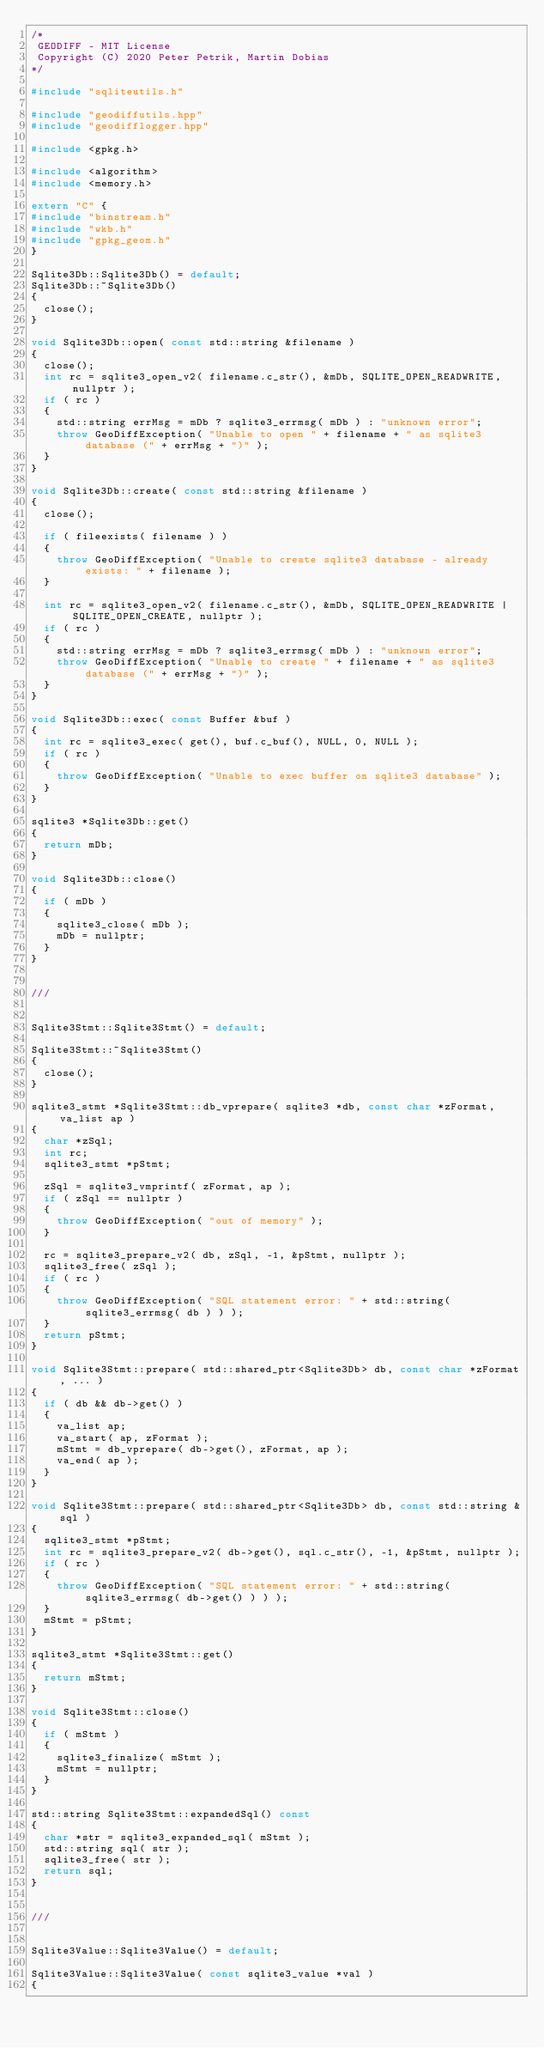Convert code to text. <code><loc_0><loc_0><loc_500><loc_500><_C++_>/*
 GEODIFF - MIT License
 Copyright (C) 2020 Peter Petrik, Martin Dobias
*/

#include "sqliteutils.h"

#include "geodiffutils.hpp"
#include "geodifflogger.hpp"

#include <gpkg.h>

#include <algorithm>
#include <memory.h>

extern "C" {
#include "binstream.h"
#include "wkb.h"
#include "gpkg_geom.h"
}

Sqlite3Db::Sqlite3Db() = default;
Sqlite3Db::~Sqlite3Db()
{
  close();
}

void Sqlite3Db::open( const std::string &filename )
{
  close();
  int rc = sqlite3_open_v2( filename.c_str(), &mDb, SQLITE_OPEN_READWRITE, nullptr );
  if ( rc )
  {
    std::string errMsg = mDb ? sqlite3_errmsg( mDb ) : "unknown error";
    throw GeoDiffException( "Unable to open " + filename + " as sqlite3 database (" + errMsg + ")" );
  }
}

void Sqlite3Db::create( const std::string &filename )
{
  close();

  if ( fileexists( filename ) )
  {
    throw GeoDiffException( "Unable to create sqlite3 database - already exists: " + filename );
  }

  int rc = sqlite3_open_v2( filename.c_str(), &mDb, SQLITE_OPEN_READWRITE | SQLITE_OPEN_CREATE, nullptr );
  if ( rc )
  {
    std::string errMsg = mDb ? sqlite3_errmsg( mDb ) : "unknown error";
    throw GeoDiffException( "Unable to create " + filename + " as sqlite3 database (" + errMsg + ")" );
  }
}

void Sqlite3Db::exec( const Buffer &buf )
{
  int rc = sqlite3_exec( get(), buf.c_buf(), NULL, 0, NULL );
  if ( rc )
  {
    throw GeoDiffException( "Unable to exec buffer on sqlite3 database" );
  }
}

sqlite3 *Sqlite3Db::get()
{
  return mDb;
}

void Sqlite3Db::close()
{
  if ( mDb )
  {
    sqlite3_close( mDb );
    mDb = nullptr;
  }
}


///


Sqlite3Stmt::Sqlite3Stmt() = default;

Sqlite3Stmt::~Sqlite3Stmt()
{
  close();
}

sqlite3_stmt *Sqlite3Stmt::db_vprepare( sqlite3 *db, const char *zFormat, va_list ap )
{
  char *zSql;
  int rc;
  sqlite3_stmt *pStmt;

  zSql = sqlite3_vmprintf( zFormat, ap );
  if ( zSql == nullptr )
  {
    throw GeoDiffException( "out of memory" );
  }

  rc = sqlite3_prepare_v2( db, zSql, -1, &pStmt, nullptr );
  sqlite3_free( zSql );
  if ( rc )
  {
    throw GeoDiffException( "SQL statement error: " + std::string( sqlite3_errmsg( db ) ) );
  }
  return pStmt;
}

void Sqlite3Stmt::prepare( std::shared_ptr<Sqlite3Db> db, const char *zFormat, ... )
{
  if ( db && db->get() )
  {
    va_list ap;
    va_start( ap, zFormat );
    mStmt = db_vprepare( db->get(), zFormat, ap );
    va_end( ap );
  }
}

void Sqlite3Stmt::prepare( std::shared_ptr<Sqlite3Db> db, const std::string &sql )
{
  sqlite3_stmt *pStmt;
  int rc = sqlite3_prepare_v2( db->get(), sql.c_str(), -1, &pStmt, nullptr );
  if ( rc )
  {
    throw GeoDiffException( "SQL statement error: " + std::string( sqlite3_errmsg( db->get() ) ) );
  }
  mStmt = pStmt;
}

sqlite3_stmt *Sqlite3Stmt::get()
{
  return mStmt;
}

void Sqlite3Stmt::close()
{
  if ( mStmt )
  {
    sqlite3_finalize( mStmt );
    mStmt = nullptr;
  }
}

std::string Sqlite3Stmt::expandedSql() const
{
  char *str = sqlite3_expanded_sql( mStmt );
  std::string sql( str );
  sqlite3_free( str );
  return sql;
}


///


Sqlite3Value::Sqlite3Value() = default;

Sqlite3Value::Sqlite3Value( const sqlite3_value *val )
{</code> 